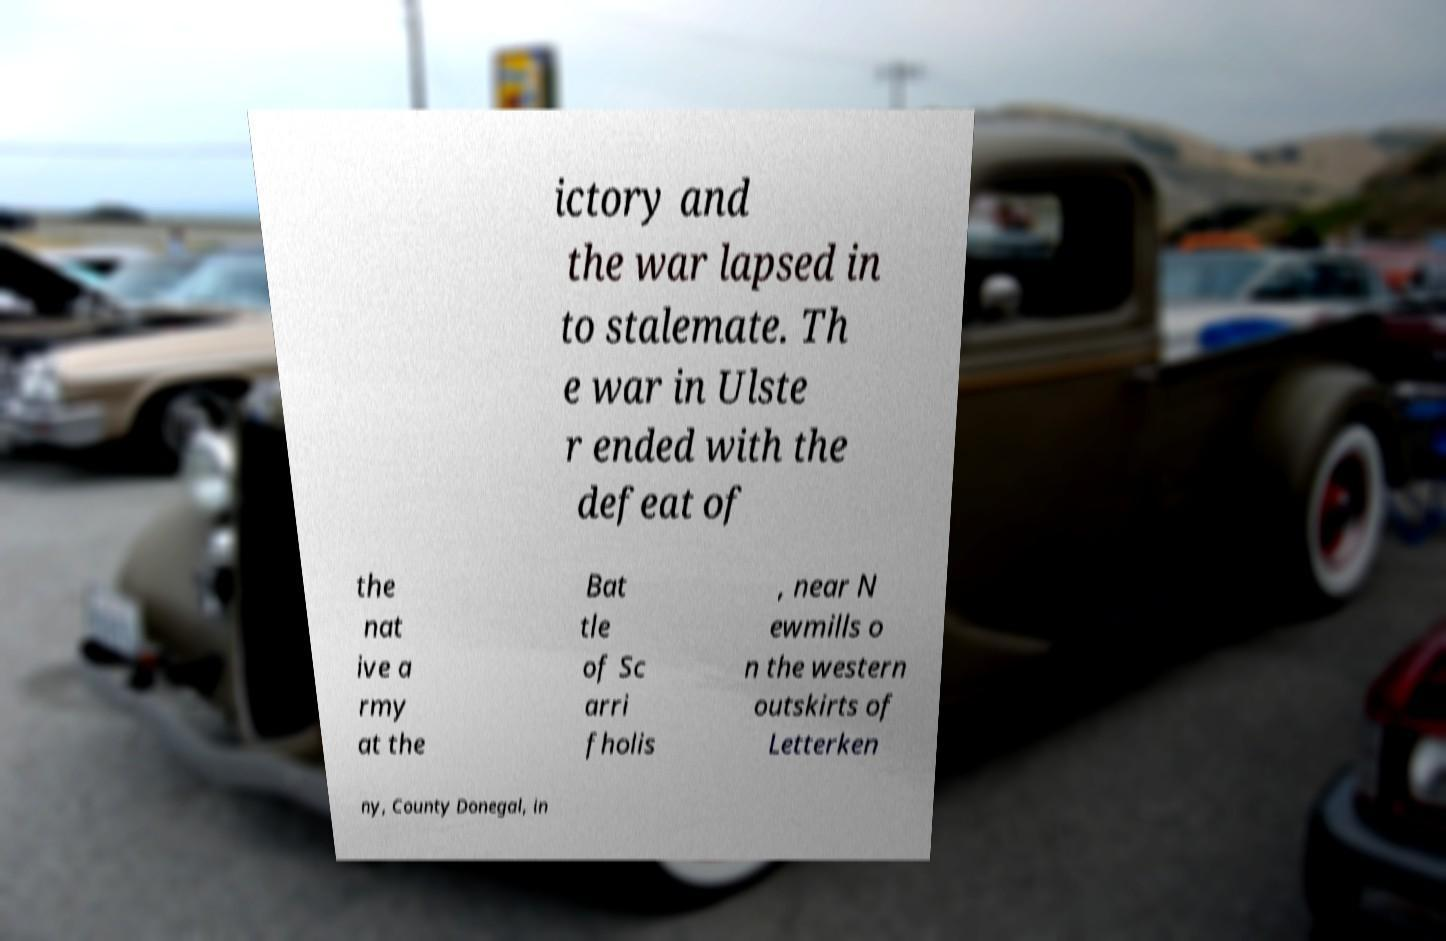There's text embedded in this image that I need extracted. Can you transcribe it verbatim? ictory and the war lapsed in to stalemate. Th e war in Ulste r ended with the defeat of the nat ive a rmy at the Bat tle of Sc arri fholis , near N ewmills o n the western outskirts of Letterken ny, County Donegal, in 